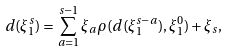Convert formula to latex. <formula><loc_0><loc_0><loc_500><loc_500>d ( \xi _ { 1 } ^ { s } ) = \sum _ { a = 1 } ^ { s - 1 } \xi _ { a } \rho ( d ( \xi _ { 1 } ^ { s - a } ) , \xi _ { 1 } ^ { 0 } ) + \xi _ { s } ,</formula> 